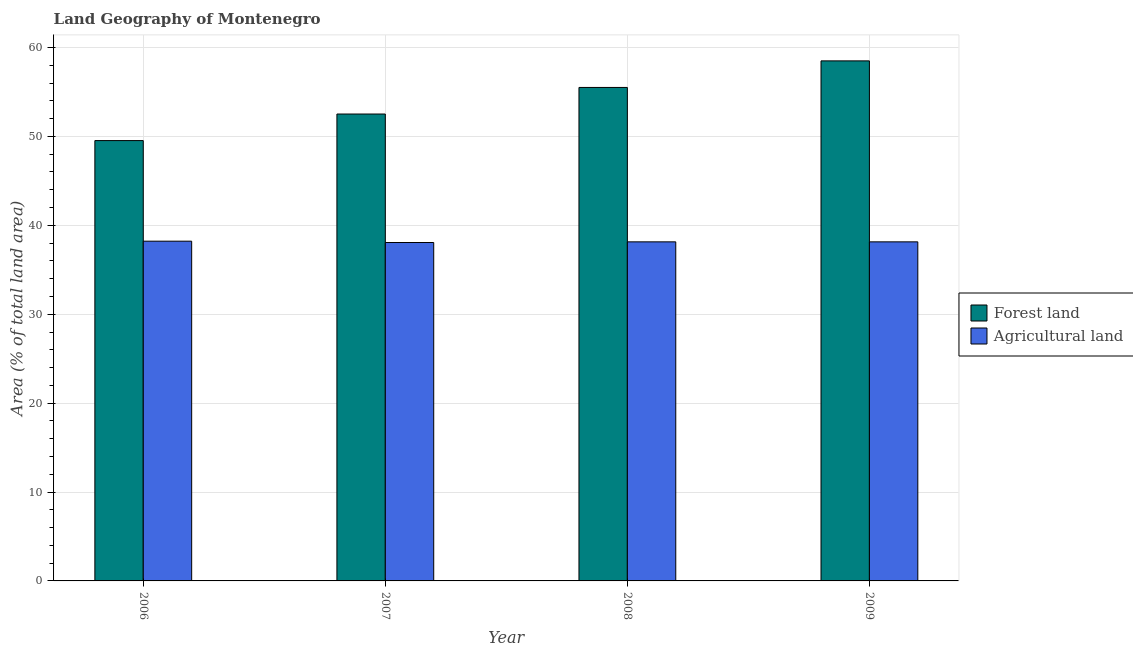How many groups of bars are there?
Offer a terse response. 4. Are the number of bars on each tick of the X-axis equal?
Ensure brevity in your answer.  Yes. How many bars are there on the 3rd tick from the left?
Offer a terse response. 2. How many bars are there on the 2nd tick from the right?
Make the answer very short. 2. In how many cases, is the number of bars for a given year not equal to the number of legend labels?
Your answer should be compact. 0. What is the percentage of land area under forests in 2008?
Keep it short and to the point. 55.51. Across all years, what is the maximum percentage of land area under forests?
Your answer should be very brief. 58.5. Across all years, what is the minimum percentage of land area under agriculture?
Offer a terse response. 38.07. In which year was the percentage of land area under agriculture maximum?
Ensure brevity in your answer.  2006. In which year was the percentage of land area under agriculture minimum?
Keep it short and to the point. 2007. What is the total percentage of land area under forests in the graph?
Offer a very short reply. 216.06. What is the difference between the percentage of land area under agriculture in 2006 and that in 2007?
Your answer should be very brief. 0.15. What is the difference between the percentage of land area under agriculture in 2009 and the percentage of land area under forests in 2006?
Give a very brief answer. -0.07. What is the average percentage of land area under forests per year?
Provide a succinct answer. 54.01. What is the ratio of the percentage of land area under forests in 2007 to that in 2008?
Offer a terse response. 0.95. What is the difference between the highest and the second highest percentage of land area under forests?
Make the answer very short. 2.99. What is the difference between the highest and the lowest percentage of land area under forests?
Your answer should be compact. 8.97. What does the 1st bar from the left in 2007 represents?
Ensure brevity in your answer.  Forest land. What does the 2nd bar from the right in 2009 represents?
Provide a succinct answer. Forest land. Are all the bars in the graph horizontal?
Your answer should be very brief. No. How many years are there in the graph?
Offer a terse response. 4. What is the difference between two consecutive major ticks on the Y-axis?
Ensure brevity in your answer.  10. Does the graph contain grids?
Give a very brief answer. Yes. What is the title of the graph?
Give a very brief answer. Land Geography of Montenegro. Does "Travel Items" appear as one of the legend labels in the graph?
Offer a very short reply. No. What is the label or title of the Y-axis?
Your answer should be compact. Area (% of total land area). What is the Area (% of total land area) in Forest land in 2006?
Offer a very short reply. 49.53. What is the Area (% of total land area) of Agricultural land in 2006?
Keep it short and to the point. 38.22. What is the Area (% of total land area) in Forest land in 2007?
Your answer should be compact. 52.52. What is the Area (% of total land area) of Agricultural land in 2007?
Your answer should be compact. 38.07. What is the Area (% of total land area) of Forest land in 2008?
Provide a succinct answer. 55.51. What is the Area (% of total land area) of Agricultural land in 2008?
Offer a terse response. 38.14. What is the Area (% of total land area) of Forest land in 2009?
Your answer should be very brief. 58.5. What is the Area (% of total land area) of Agricultural land in 2009?
Provide a succinct answer. 38.14. Across all years, what is the maximum Area (% of total land area) of Forest land?
Offer a terse response. 58.5. Across all years, what is the maximum Area (% of total land area) of Agricultural land?
Make the answer very short. 38.22. Across all years, what is the minimum Area (% of total land area) in Forest land?
Your answer should be compact. 49.53. Across all years, what is the minimum Area (% of total land area) of Agricultural land?
Make the answer very short. 38.07. What is the total Area (% of total land area) in Forest land in the graph?
Make the answer very short. 216.06. What is the total Area (% of total land area) in Agricultural land in the graph?
Keep it short and to the point. 152.57. What is the difference between the Area (% of total land area) of Forest land in 2006 and that in 2007?
Keep it short and to the point. -2.99. What is the difference between the Area (% of total land area) of Agricultural land in 2006 and that in 2007?
Offer a very short reply. 0.15. What is the difference between the Area (% of total land area) in Forest land in 2006 and that in 2008?
Your answer should be very brief. -5.98. What is the difference between the Area (% of total land area) in Agricultural land in 2006 and that in 2008?
Your answer should be very brief. 0.07. What is the difference between the Area (% of total land area) of Forest land in 2006 and that in 2009?
Keep it short and to the point. -8.97. What is the difference between the Area (% of total land area) in Agricultural land in 2006 and that in 2009?
Make the answer very short. 0.07. What is the difference between the Area (% of total land area) in Forest land in 2007 and that in 2008?
Make the answer very short. -2.99. What is the difference between the Area (% of total land area) of Agricultural land in 2007 and that in 2008?
Offer a terse response. -0.07. What is the difference between the Area (% of total land area) in Forest land in 2007 and that in 2009?
Offer a terse response. -5.98. What is the difference between the Area (% of total land area) in Agricultural land in 2007 and that in 2009?
Provide a short and direct response. -0.07. What is the difference between the Area (% of total land area) in Forest land in 2008 and that in 2009?
Your answer should be very brief. -2.99. What is the difference between the Area (% of total land area) of Agricultural land in 2008 and that in 2009?
Provide a short and direct response. 0. What is the difference between the Area (% of total land area) in Forest land in 2006 and the Area (% of total land area) in Agricultural land in 2007?
Make the answer very short. 11.46. What is the difference between the Area (% of total land area) of Forest land in 2006 and the Area (% of total land area) of Agricultural land in 2008?
Provide a short and direct response. 11.39. What is the difference between the Area (% of total land area) of Forest land in 2006 and the Area (% of total land area) of Agricultural land in 2009?
Ensure brevity in your answer.  11.39. What is the difference between the Area (% of total land area) in Forest land in 2007 and the Area (% of total land area) in Agricultural land in 2008?
Your response must be concise. 14.38. What is the difference between the Area (% of total land area) in Forest land in 2007 and the Area (% of total land area) in Agricultural land in 2009?
Offer a terse response. 14.38. What is the difference between the Area (% of total land area) in Forest land in 2008 and the Area (% of total land area) in Agricultural land in 2009?
Your answer should be compact. 17.37. What is the average Area (% of total land area) in Forest land per year?
Keep it short and to the point. 54.01. What is the average Area (% of total land area) in Agricultural land per year?
Offer a very short reply. 38.14. In the year 2006, what is the difference between the Area (% of total land area) in Forest land and Area (% of total land area) in Agricultural land?
Offer a very short reply. 11.32. In the year 2007, what is the difference between the Area (% of total land area) of Forest land and Area (% of total land area) of Agricultural land?
Your response must be concise. 14.45. In the year 2008, what is the difference between the Area (% of total land area) of Forest land and Area (% of total land area) of Agricultural land?
Offer a terse response. 17.37. In the year 2009, what is the difference between the Area (% of total land area) of Forest land and Area (% of total land area) of Agricultural land?
Your answer should be compact. 20.36. What is the ratio of the Area (% of total land area) of Forest land in 2006 to that in 2007?
Your answer should be very brief. 0.94. What is the ratio of the Area (% of total land area) in Agricultural land in 2006 to that in 2007?
Your response must be concise. 1. What is the ratio of the Area (% of total land area) in Forest land in 2006 to that in 2008?
Offer a terse response. 0.89. What is the ratio of the Area (% of total land area) of Forest land in 2006 to that in 2009?
Ensure brevity in your answer.  0.85. What is the ratio of the Area (% of total land area) in Agricultural land in 2006 to that in 2009?
Keep it short and to the point. 1. What is the ratio of the Area (% of total land area) of Forest land in 2007 to that in 2008?
Provide a short and direct response. 0.95. What is the ratio of the Area (% of total land area) of Agricultural land in 2007 to that in 2008?
Offer a very short reply. 1. What is the ratio of the Area (% of total land area) in Forest land in 2007 to that in 2009?
Your answer should be very brief. 0.9. What is the ratio of the Area (% of total land area) in Agricultural land in 2007 to that in 2009?
Your answer should be very brief. 1. What is the ratio of the Area (% of total land area) of Forest land in 2008 to that in 2009?
Offer a terse response. 0.95. What is the difference between the highest and the second highest Area (% of total land area) in Forest land?
Your answer should be compact. 2.99. What is the difference between the highest and the second highest Area (% of total land area) in Agricultural land?
Provide a short and direct response. 0.07. What is the difference between the highest and the lowest Area (% of total land area) in Forest land?
Provide a short and direct response. 8.97. What is the difference between the highest and the lowest Area (% of total land area) of Agricultural land?
Keep it short and to the point. 0.15. 